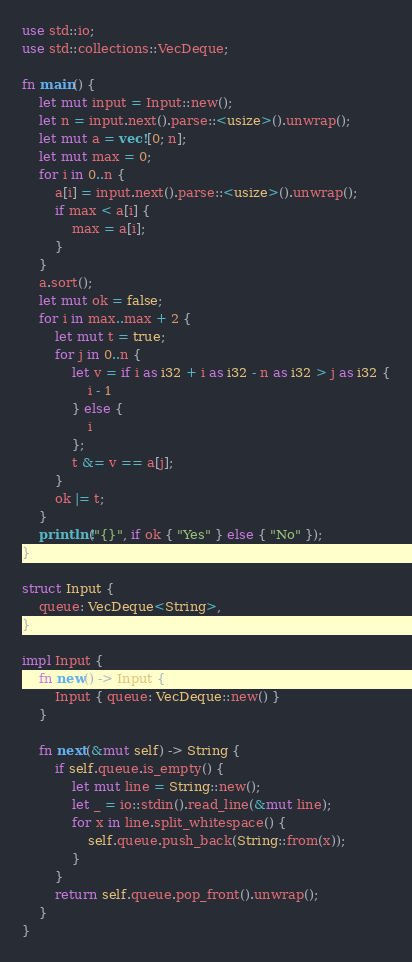<code> <loc_0><loc_0><loc_500><loc_500><_Rust_>use std::io;
use std::collections::VecDeque;

fn main() {
    let mut input = Input::new();
    let n = input.next().parse::<usize>().unwrap();
    let mut a = vec![0; n];
    let mut max = 0;
    for i in 0..n {
        a[i] = input.next().parse::<usize>().unwrap();
        if max < a[i] {
            max = a[i];
        }
    }
    a.sort();
    let mut ok = false;
    for i in max..max + 2 {
        let mut t = true;
        for j in 0..n {
            let v = if i as i32 + i as i32 - n as i32 > j as i32 {
                i - 1
            } else {
                i
            };
            t &= v == a[j];
        }
        ok |= t;
    }
    println!("{}", if ok { "Yes" } else { "No" });
}

struct Input {
    queue: VecDeque<String>,
}

impl Input {
    fn new() -> Input {
        Input { queue: VecDeque::new() }
    }

    fn next(&mut self) -> String {
        if self.queue.is_empty() {
            let mut line = String::new();
            let _ = io::stdin().read_line(&mut line);
            for x in line.split_whitespace() {
                self.queue.push_back(String::from(x));
            }
        }
        return self.queue.pop_front().unwrap();
    }
}

</code> 